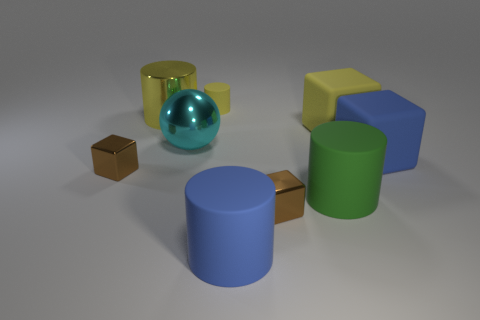Add 1 blocks. How many objects exist? 10 Subtract all big cylinders. How many cylinders are left? 1 Subtract all brown blocks. How many blocks are left? 2 Subtract 4 cubes. How many cubes are left? 0 Add 8 tiny shiny cubes. How many tiny shiny cubes are left? 10 Add 6 small brown objects. How many small brown objects exist? 8 Subtract 1 blue blocks. How many objects are left? 8 Subtract all balls. How many objects are left? 8 Subtract all gray cylinders. Subtract all purple cubes. How many cylinders are left? 4 Subtract all yellow spheres. How many blue cylinders are left? 1 